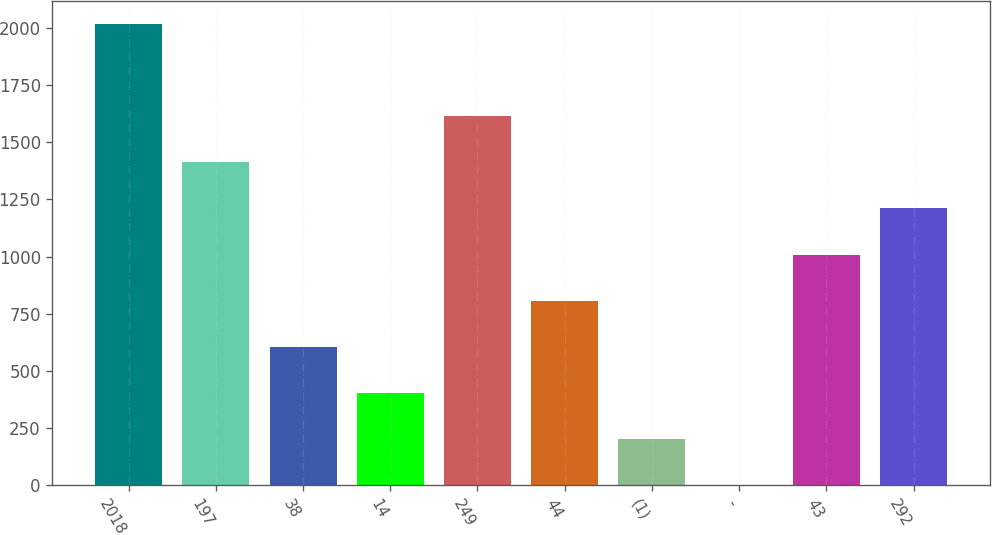Convert chart. <chart><loc_0><loc_0><loc_500><loc_500><bar_chart><fcel>2018<fcel>197<fcel>38<fcel>14<fcel>249<fcel>44<fcel>(1)<fcel>-<fcel>43<fcel>292<nl><fcel>2016<fcel>1411.5<fcel>605.5<fcel>404<fcel>1613<fcel>807<fcel>202.5<fcel>1<fcel>1008.5<fcel>1210<nl></chart> 